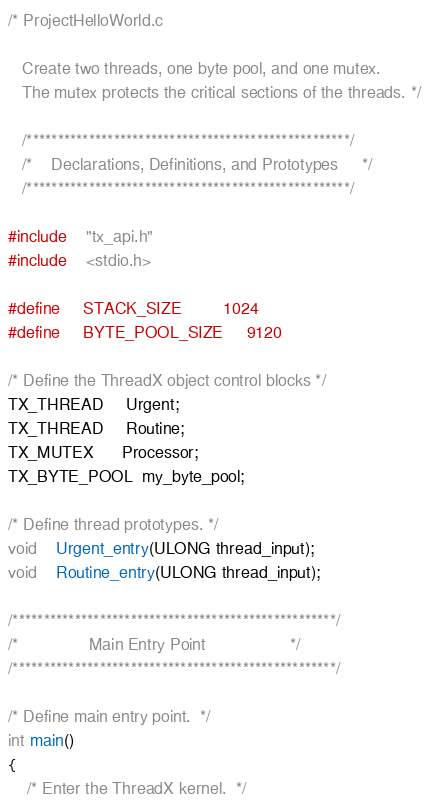Convert code to text. <code><loc_0><loc_0><loc_500><loc_500><_C_>/* ProjectHelloWorld.c

   Create two threads, one byte pool, and one mutex.
   The mutex protects the critical sections of the threads. */

   /****************************************************/
   /*    Declarations, Definitions, and Prototypes     */
   /****************************************************/

#include    "tx_api.h"
#include    <stdio.h>

#define     STACK_SIZE         1024
#define     BYTE_POOL_SIZE     9120

/* Define the ThreadX object control blocks */
TX_THREAD     Urgent;
TX_THREAD     Routine;
TX_MUTEX      Processor;
TX_BYTE_POOL  my_byte_pool;

/* Define thread prototypes. */
void    Urgent_entry(ULONG thread_input);
void    Routine_entry(ULONG thread_input);

/****************************************************/
/*               Main Entry Point                  */
/****************************************************/

/* Define main entry point.  */
int main()
{
    /* Enter the ThreadX kernel.  */</code> 